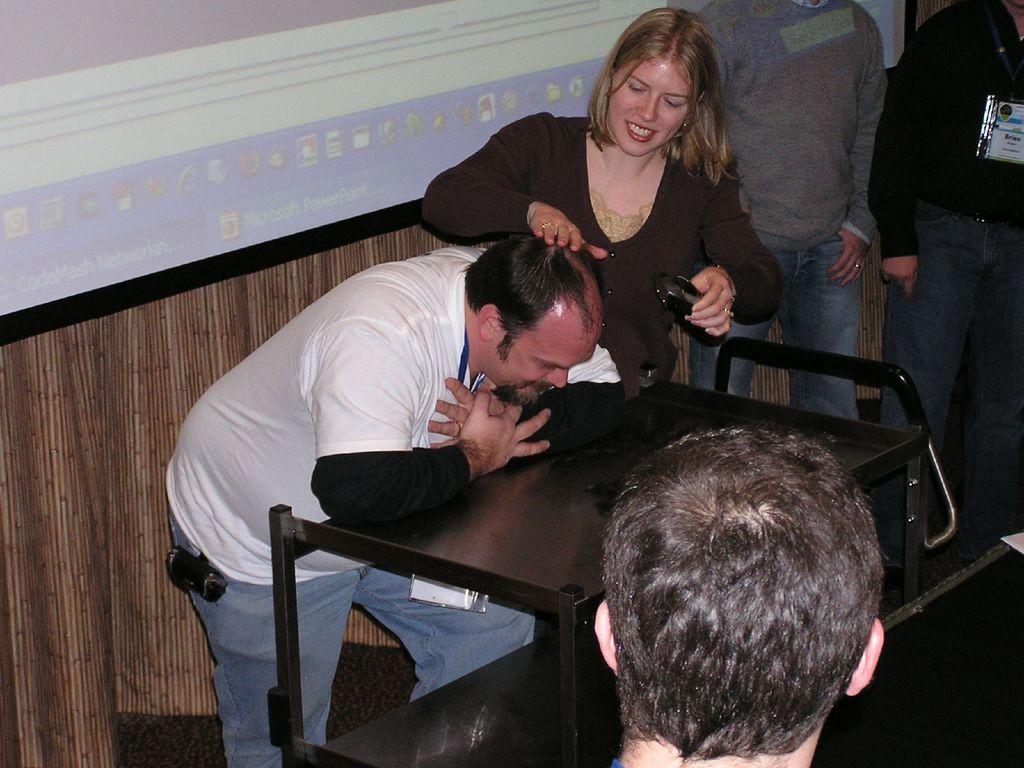Describe this image in one or two sentences. In the middle there is a table , in front of the table there are two people ,on that In the middle there is a woman she wear black t shirt she is smiling ,her hair is short. On the left there is a man ,he wear white t shirt and trouser. On the right there are two men standing. In the middle there is a man. In the background there is a projector screen. 